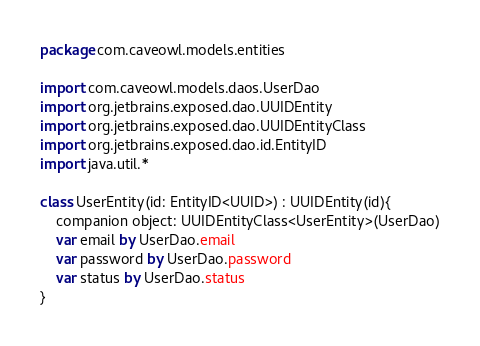<code> <loc_0><loc_0><loc_500><loc_500><_Kotlin_>package com.caveowl.models.entities

import com.caveowl.models.daos.UserDao
import org.jetbrains.exposed.dao.UUIDEntity
import org.jetbrains.exposed.dao.UUIDEntityClass
import org.jetbrains.exposed.dao.id.EntityID
import java.util.*

class UserEntity(id: EntityID<UUID>) : UUIDEntity(id){
    companion object: UUIDEntityClass<UserEntity>(UserDao)
    var email by UserDao.email
    var password by UserDao.password
    var status by UserDao.status
}
</code> 